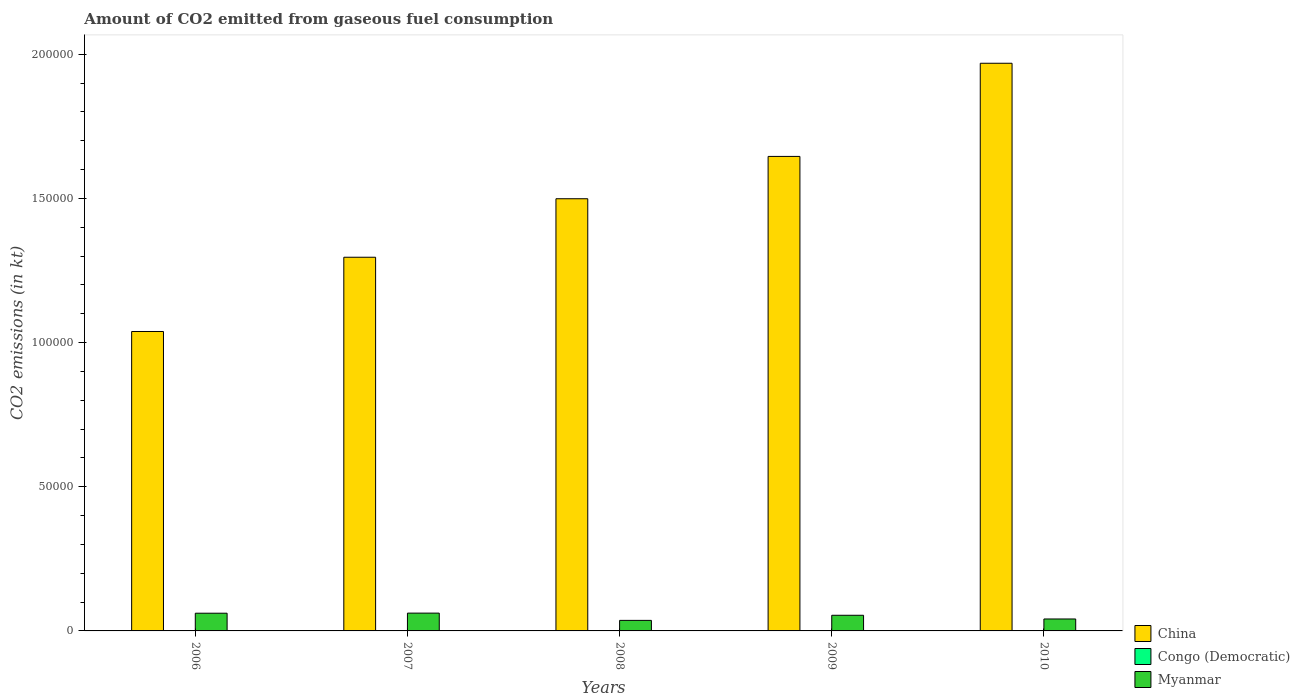How many different coloured bars are there?
Your answer should be very brief. 3. In how many cases, is the number of bars for a given year not equal to the number of legend labels?
Your response must be concise. 0. What is the amount of CO2 emitted in China in 2006?
Provide a succinct answer. 1.04e+05. Across all years, what is the maximum amount of CO2 emitted in China?
Keep it short and to the point. 1.97e+05. Across all years, what is the minimum amount of CO2 emitted in Myanmar?
Your response must be concise. 3652.33. What is the total amount of CO2 emitted in Myanmar in the graph?
Your response must be concise. 2.55e+04. What is the difference between the amount of CO2 emitted in Myanmar in 2007 and that in 2010?
Provide a short and direct response. 2027.85. What is the difference between the amount of CO2 emitted in China in 2008 and the amount of CO2 emitted in Myanmar in 2010?
Offer a terse response. 1.46e+05. What is the average amount of CO2 emitted in Congo (Democratic) per year?
Keep it short and to the point. 13.2. In the year 2010, what is the difference between the amount of CO2 emitted in China and amount of CO2 emitted in Congo (Democratic)?
Your response must be concise. 1.97e+05. What is the ratio of the amount of CO2 emitted in China in 2006 to that in 2010?
Offer a terse response. 0.53. Is the amount of CO2 emitted in Myanmar in 2006 less than that in 2010?
Offer a very short reply. No. What is the difference between the highest and the second highest amount of CO2 emitted in Myanmar?
Keep it short and to the point. 29.34. What is the difference between the highest and the lowest amount of CO2 emitted in Myanmar?
Give a very brief answer. 2519.23. What does the 3rd bar from the left in 2007 represents?
Offer a terse response. Myanmar. What does the 2nd bar from the right in 2007 represents?
Offer a terse response. Congo (Democratic). How many bars are there?
Provide a succinct answer. 15. What is the difference between two consecutive major ticks on the Y-axis?
Offer a very short reply. 5.00e+04. Are the values on the major ticks of Y-axis written in scientific E-notation?
Your answer should be compact. No. Where does the legend appear in the graph?
Provide a succinct answer. Bottom right. What is the title of the graph?
Your response must be concise. Amount of CO2 emitted from gaseous fuel consumption. Does "Maldives" appear as one of the legend labels in the graph?
Provide a short and direct response. No. What is the label or title of the X-axis?
Your answer should be compact. Years. What is the label or title of the Y-axis?
Your answer should be compact. CO2 emissions (in kt). What is the CO2 emissions (in kt) of China in 2006?
Your answer should be compact. 1.04e+05. What is the CO2 emissions (in kt) in Congo (Democratic) in 2006?
Your answer should be very brief. 7.33. What is the CO2 emissions (in kt) in Myanmar in 2006?
Your response must be concise. 6142.23. What is the CO2 emissions (in kt) of China in 2007?
Give a very brief answer. 1.30e+05. What is the CO2 emissions (in kt) of Congo (Democratic) in 2007?
Your answer should be very brief. 14.67. What is the CO2 emissions (in kt) in Myanmar in 2007?
Your response must be concise. 6171.56. What is the CO2 emissions (in kt) in China in 2008?
Your response must be concise. 1.50e+05. What is the CO2 emissions (in kt) in Congo (Democratic) in 2008?
Give a very brief answer. 14.67. What is the CO2 emissions (in kt) in Myanmar in 2008?
Offer a very short reply. 3652.33. What is the CO2 emissions (in kt) in China in 2009?
Your answer should be compact. 1.65e+05. What is the CO2 emissions (in kt) of Congo (Democratic) in 2009?
Offer a very short reply. 14.67. What is the CO2 emissions (in kt) in Myanmar in 2009?
Keep it short and to the point. 5427.16. What is the CO2 emissions (in kt) of China in 2010?
Your answer should be compact. 1.97e+05. What is the CO2 emissions (in kt) of Congo (Democratic) in 2010?
Offer a very short reply. 14.67. What is the CO2 emissions (in kt) in Myanmar in 2010?
Provide a short and direct response. 4143.71. Across all years, what is the maximum CO2 emissions (in kt) of China?
Give a very brief answer. 1.97e+05. Across all years, what is the maximum CO2 emissions (in kt) of Congo (Democratic)?
Ensure brevity in your answer.  14.67. Across all years, what is the maximum CO2 emissions (in kt) in Myanmar?
Make the answer very short. 6171.56. Across all years, what is the minimum CO2 emissions (in kt) of China?
Offer a terse response. 1.04e+05. Across all years, what is the minimum CO2 emissions (in kt) in Congo (Democratic)?
Ensure brevity in your answer.  7.33. Across all years, what is the minimum CO2 emissions (in kt) in Myanmar?
Give a very brief answer. 3652.33. What is the total CO2 emissions (in kt) in China in the graph?
Offer a terse response. 7.45e+05. What is the total CO2 emissions (in kt) of Congo (Democratic) in the graph?
Offer a terse response. 66.01. What is the total CO2 emissions (in kt) in Myanmar in the graph?
Provide a short and direct response. 2.55e+04. What is the difference between the CO2 emissions (in kt) in China in 2006 and that in 2007?
Make the answer very short. -2.57e+04. What is the difference between the CO2 emissions (in kt) in Congo (Democratic) in 2006 and that in 2007?
Provide a short and direct response. -7.33. What is the difference between the CO2 emissions (in kt) of Myanmar in 2006 and that in 2007?
Ensure brevity in your answer.  -29.34. What is the difference between the CO2 emissions (in kt) of China in 2006 and that in 2008?
Provide a succinct answer. -4.60e+04. What is the difference between the CO2 emissions (in kt) in Congo (Democratic) in 2006 and that in 2008?
Keep it short and to the point. -7.33. What is the difference between the CO2 emissions (in kt) in Myanmar in 2006 and that in 2008?
Your response must be concise. 2489.89. What is the difference between the CO2 emissions (in kt) in China in 2006 and that in 2009?
Offer a very short reply. -6.07e+04. What is the difference between the CO2 emissions (in kt) in Congo (Democratic) in 2006 and that in 2009?
Keep it short and to the point. -7.33. What is the difference between the CO2 emissions (in kt) in Myanmar in 2006 and that in 2009?
Offer a very short reply. 715.07. What is the difference between the CO2 emissions (in kt) in China in 2006 and that in 2010?
Give a very brief answer. -9.30e+04. What is the difference between the CO2 emissions (in kt) in Congo (Democratic) in 2006 and that in 2010?
Keep it short and to the point. -7.33. What is the difference between the CO2 emissions (in kt) in Myanmar in 2006 and that in 2010?
Provide a short and direct response. 1998.52. What is the difference between the CO2 emissions (in kt) in China in 2007 and that in 2008?
Provide a succinct answer. -2.03e+04. What is the difference between the CO2 emissions (in kt) in Congo (Democratic) in 2007 and that in 2008?
Provide a short and direct response. 0. What is the difference between the CO2 emissions (in kt) in Myanmar in 2007 and that in 2008?
Make the answer very short. 2519.23. What is the difference between the CO2 emissions (in kt) in China in 2007 and that in 2009?
Keep it short and to the point. -3.50e+04. What is the difference between the CO2 emissions (in kt) in Congo (Democratic) in 2007 and that in 2009?
Your answer should be compact. 0. What is the difference between the CO2 emissions (in kt) in Myanmar in 2007 and that in 2009?
Give a very brief answer. 744.4. What is the difference between the CO2 emissions (in kt) of China in 2007 and that in 2010?
Ensure brevity in your answer.  -6.73e+04. What is the difference between the CO2 emissions (in kt) in Congo (Democratic) in 2007 and that in 2010?
Your answer should be compact. 0. What is the difference between the CO2 emissions (in kt) of Myanmar in 2007 and that in 2010?
Give a very brief answer. 2027.85. What is the difference between the CO2 emissions (in kt) in China in 2008 and that in 2009?
Your answer should be compact. -1.47e+04. What is the difference between the CO2 emissions (in kt) of Congo (Democratic) in 2008 and that in 2009?
Your response must be concise. 0. What is the difference between the CO2 emissions (in kt) in Myanmar in 2008 and that in 2009?
Your answer should be compact. -1774.83. What is the difference between the CO2 emissions (in kt) of China in 2008 and that in 2010?
Give a very brief answer. -4.70e+04. What is the difference between the CO2 emissions (in kt) of Congo (Democratic) in 2008 and that in 2010?
Give a very brief answer. 0. What is the difference between the CO2 emissions (in kt) in Myanmar in 2008 and that in 2010?
Ensure brevity in your answer.  -491.38. What is the difference between the CO2 emissions (in kt) in China in 2009 and that in 2010?
Ensure brevity in your answer.  -3.23e+04. What is the difference between the CO2 emissions (in kt) of Congo (Democratic) in 2009 and that in 2010?
Provide a succinct answer. 0. What is the difference between the CO2 emissions (in kt) in Myanmar in 2009 and that in 2010?
Provide a short and direct response. 1283.45. What is the difference between the CO2 emissions (in kt) of China in 2006 and the CO2 emissions (in kt) of Congo (Democratic) in 2007?
Your response must be concise. 1.04e+05. What is the difference between the CO2 emissions (in kt) of China in 2006 and the CO2 emissions (in kt) of Myanmar in 2007?
Your answer should be very brief. 9.77e+04. What is the difference between the CO2 emissions (in kt) in Congo (Democratic) in 2006 and the CO2 emissions (in kt) in Myanmar in 2007?
Provide a succinct answer. -6164.23. What is the difference between the CO2 emissions (in kt) in China in 2006 and the CO2 emissions (in kt) in Congo (Democratic) in 2008?
Your answer should be compact. 1.04e+05. What is the difference between the CO2 emissions (in kt) of China in 2006 and the CO2 emissions (in kt) of Myanmar in 2008?
Provide a succinct answer. 1.00e+05. What is the difference between the CO2 emissions (in kt) of Congo (Democratic) in 2006 and the CO2 emissions (in kt) of Myanmar in 2008?
Your answer should be compact. -3645. What is the difference between the CO2 emissions (in kt) of China in 2006 and the CO2 emissions (in kt) of Congo (Democratic) in 2009?
Provide a short and direct response. 1.04e+05. What is the difference between the CO2 emissions (in kt) of China in 2006 and the CO2 emissions (in kt) of Myanmar in 2009?
Make the answer very short. 9.84e+04. What is the difference between the CO2 emissions (in kt) of Congo (Democratic) in 2006 and the CO2 emissions (in kt) of Myanmar in 2009?
Keep it short and to the point. -5419.83. What is the difference between the CO2 emissions (in kt) of China in 2006 and the CO2 emissions (in kt) of Congo (Democratic) in 2010?
Offer a very short reply. 1.04e+05. What is the difference between the CO2 emissions (in kt) of China in 2006 and the CO2 emissions (in kt) of Myanmar in 2010?
Offer a very short reply. 9.97e+04. What is the difference between the CO2 emissions (in kt) of Congo (Democratic) in 2006 and the CO2 emissions (in kt) of Myanmar in 2010?
Your response must be concise. -4136.38. What is the difference between the CO2 emissions (in kt) in China in 2007 and the CO2 emissions (in kt) in Congo (Democratic) in 2008?
Ensure brevity in your answer.  1.30e+05. What is the difference between the CO2 emissions (in kt) of China in 2007 and the CO2 emissions (in kt) of Myanmar in 2008?
Provide a succinct answer. 1.26e+05. What is the difference between the CO2 emissions (in kt) in Congo (Democratic) in 2007 and the CO2 emissions (in kt) in Myanmar in 2008?
Your answer should be very brief. -3637.66. What is the difference between the CO2 emissions (in kt) of China in 2007 and the CO2 emissions (in kt) of Congo (Democratic) in 2009?
Offer a terse response. 1.30e+05. What is the difference between the CO2 emissions (in kt) in China in 2007 and the CO2 emissions (in kt) in Myanmar in 2009?
Your response must be concise. 1.24e+05. What is the difference between the CO2 emissions (in kt) in Congo (Democratic) in 2007 and the CO2 emissions (in kt) in Myanmar in 2009?
Your answer should be compact. -5412.49. What is the difference between the CO2 emissions (in kt) of China in 2007 and the CO2 emissions (in kt) of Congo (Democratic) in 2010?
Ensure brevity in your answer.  1.30e+05. What is the difference between the CO2 emissions (in kt) of China in 2007 and the CO2 emissions (in kt) of Myanmar in 2010?
Offer a very short reply. 1.25e+05. What is the difference between the CO2 emissions (in kt) in Congo (Democratic) in 2007 and the CO2 emissions (in kt) in Myanmar in 2010?
Make the answer very short. -4129.04. What is the difference between the CO2 emissions (in kt) of China in 2008 and the CO2 emissions (in kt) of Congo (Democratic) in 2009?
Make the answer very short. 1.50e+05. What is the difference between the CO2 emissions (in kt) in China in 2008 and the CO2 emissions (in kt) in Myanmar in 2009?
Provide a succinct answer. 1.44e+05. What is the difference between the CO2 emissions (in kt) in Congo (Democratic) in 2008 and the CO2 emissions (in kt) in Myanmar in 2009?
Your answer should be compact. -5412.49. What is the difference between the CO2 emissions (in kt) of China in 2008 and the CO2 emissions (in kt) of Congo (Democratic) in 2010?
Provide a short and direct response. 1.50e+05. What is the difference between the CO2 emissions (in kt) in China in 2008 and the CO2 emissions (in kt) in Myanmar in 2010?
Your answer should be compact. 1.46e+05. What is the difference between the CO2 emissions (in kt) in Congo (Democratic) in 2008 and the CO2 emissions (in kt) in Myanmar in 2010?
Your answer should be very brief. -4129.04. What is the difference between the CO2 emissions (in kt) in China in 2009 and the CO2 emissions (in kt) in Congo (Democratic) in 2010?
Give a very brief answer. 1.65e+05. What is the difference between the CO2 emissions (in kt) in China in 2009 and the CO2 emissions (in kt) in Myanmar in 2010?
Ensure brevity in your answer.  1.60e+05. What is the difference between the CO2 emissions (in kt) in Congo (Democratic) in 2009 and the CO2 emissions (in kt) in Myanmar in 2010?
Offer a terse response. -4129.04. What is the average CO2 emissions (in kt) in China per year?
Make the answer very short. 1.49e+05. What is the average CO2 emissions (in kt) of Congo (Democratic) per year?
Ensure brevity in your answer.  13.2. What is the average CO2 emissions (in kt) of Myanmar per year?
Keep it short and to the point. 5107.4. In the year 2006, what is the difference between the CO2 emissions (in kt) in China and CO2 emissions (in kt) in Congo (Democratic)?
Make the answer very short. 1.04e+05. In the year 2006, what is the difference between the CO2 emissions (in kt) in China and CO2 emissions (in kt) in Myanmar?
Provide a succinct answer. 9.77e+04. In the year 2006, what is the difference between the CO2 emissions (in kt) of Congo (Democratic) and CO2 emissions (in kt) of Myanmar?
Make the answer very short. -6134.89. In the year 2007, what is the difference between the CO2 emissions (in kt) in China and CO2 emissions (in kt) in Congo (Democratic)?
Provide a succinct answer. 1.30e+05. In the year 2007, what is the difference between the CO2 emissions (in kt) in China and CO2 emissions (in kt) in Myanmar?
Keep it short and to the point. 1.23e+05. In the year 2007, what is the difference between the CO2 emissions (in kt) of Congo (Democratic) and CO2 emissions (in kt) of Myanmar?
Offer a very short reply. -6156.89. In the year 2008, what is the difference between the CO2 emissions (in kt) in China and CO2 emissions (in kt) in Congo (Democratic)?
Offer a terse response. 1.50e+05. In the year 2008, what is the difference between the CO2 emissions (in kt) of China and CO2 emissions (in kt) of Myanmar?
Offer a very short reply. 1.46e+05. In the year 2008, what is the difference between the CO2 emissions (in kt) in Congo (Democratic) and CO2 emissions (in kt) in Myanmar?
Make the answer very short. -3637.66. In the year 2009, what is the difference between the CO2 emissions (in kt) in China and CO2 emissions (in kt) in Congo (Democratic)?
Your response must be concise. 1.65e+05. In the year 2009, what is the difference between the CO2 emissions (in kt) in China and CO2 emissions (in kt) in Myanmar?
Your answer should be very brief. 1.59e+05. In the year 2009, what is the difference between the CO2 emissions (in kt) of Congo (Democratic) and CO2 emissions (in kt) of Myanmar?
Provide a short and direct response. -5412.49. In the year 2010, what is the difference between the CO2 emissions (in kt) in China and CO2 emissions (in kt) in Congo (Democratic)?
Give a very brief answer. 1.97e+05. In the year 2010, what is the difference between the CO2 emissions (in kt) in China and CO2 emissions (in kt) in Myanmar?
Offer a terse response. 1.93e+05. In the year 2010, what is the difference between the CO2 emissions (in kt) of Congo (Democratic) and CO2 emissions (in kt) of Myanmar?
Provide a short and direct response. -4129.04. What is the ratio of the CO2 emissions (in kt) of China in 2006 to that in 2007?
Give a very brief answer. 0.8. What is the ratio of the CO2 emissions (in kt) of Congo (Democratic) in 2006 to that in 2007?
Offer a terse response. 0.5. What is the ratio of the CO2 emissions (in kt) in China in 2006 to that in 2008?
Your response must be concise. 0.69. What is the ratio of the CO2 emissions (in kt) in Myanmar in 2006 to that in 2008?
Provide a succinct answer. 1.68. What is the ratio of the CO2 emissions (in kt) of China in 2006 to that in 2009?
Offer a very short reply. 0.63. What is the ratio of the CO2 emissions (in kt) in Myanmar in 2006 to that in 2009?
Ensure brevity in your answer.  1.13. What is the ratio of the CO2 emissions (in kt) of China in 2006 to that in 2010?
Provide a succinct answer. 0.53. What is the ratio of the CO2 emissions (in kt) in Myanmar in 2006 to that in 2010?
Offer a very short reply. 1.48. What is the ratio of the CO2 emissions (in kt) in China in 2007 to that in 2008?
Give a very brief answer. 0.86. What is the ratio of the CO2 emissions (in kt) of Myanmar in 2007 to that in 2008?
Make the answer very short. 1.69. What is the ratio of the CO2 emissions (in kt) in China in 2007 to that in 2009?
Make the answer very short. 0.79. What is the ratio of the CO2 emissions (in kt) of Myanmar in 2007 to that in 2009?
Ensure brevity in your answer.  1.14. What is the ratio of the CO2 emissions (in kt) in China in 2007 to that in 2010?
Offer a very short reply. 0.66. What is the ratio of the CO2 emissions (in kt) in Myanmar in 2007 to that in 2010?
Keep it short and to the point. 1.49. What is the ratio of the CO2 emissions (in kt) of China in 2008 to that in 2009?
Keep it short and to the point. 0.91. What is the ratio of the CO2 emissions (in kt) of Congo (Democratic) in 2008 to that in 2009?
Your response must be concise. 1. What is the ratio of the CO2 emissions (in kt) in Myanmar in 2008 to that in 2009?
Offer a terse response. 0.67. What is the ratio of the CO2 emissions (in kt) in China in 2008 to that in 2010?
Make the answer very short. 0.76. What is the ratio of the CO2 emissions (in kt) in Congo (Democratic) in 2008 to that in 2010?
Offer a terse response. 1. What is the ratio of the CO2 emissions (in kt) in Myanmar in 2008 to that in 2010?
Your answer should be compact. 0.88. What is the ratio of the CO2 emissions (in kt) of China in 2009 to that in 2010?
Your answer should be very brief. 0.84. What is the ratio of the CO2 emissions (in kt) in Congo (Democratic) in 2009 to that in 2010?
Give a very brief answer. 1. What is the ratio of the CO2 emissions (in kt) of Myanmar in 2009 to that in 2010?
Make the answer very short. 1.31. What is the difference between the highest and the second highest CO2 emissions (in kt) in China?
Your answer should be compact. 3.23e+04. What is the difference between the highest and the second highest CO2 emissions (in kt) in Congo (Democratic)?
Give a very brief answer. 0. What is the difference between the highest and the second highest CO2 emissions (in kt) in Myanmar?
Offer a very short reply. 29.34. What is the difference between the highest and the lowest CO2 emissions (in kt) of China?
Offer a terse response. 9.30e+04. What is the difference between the highest and the lowest CO2 emissions (in kt) of Congo (Democratic)?
Make the answer very short. 7.33. What is the difference between the highest and the lowest CO2 emissions (in kt) in Myanmar?
Offer a very short reply. 2519.23. 